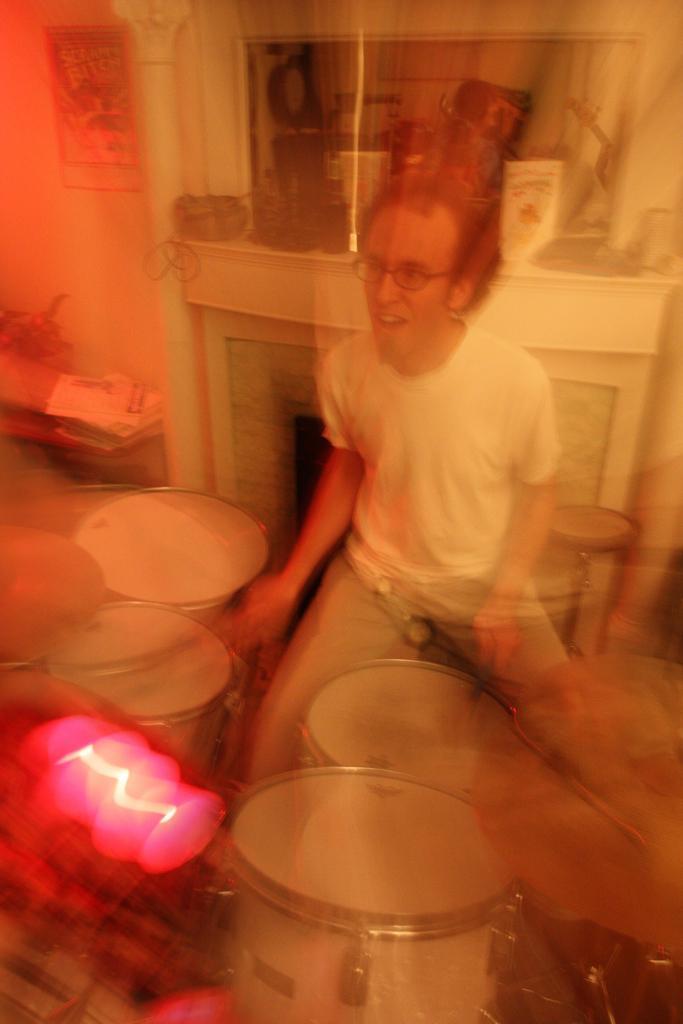In one or two sentences, can you explain what this image depicts? This picture shows a man playing a drums, sitting on the stool. In the background there is a shelf which some things were placed. 